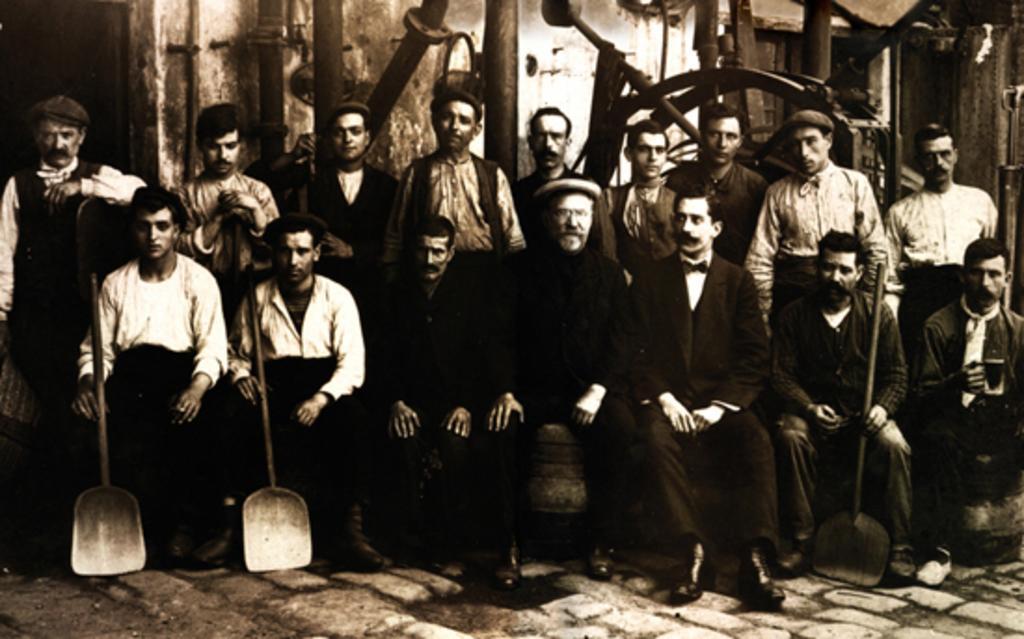Please provide a concise description of this image. In this image we can see some group of persons sitting and some are standing holding some things in their hands, posing for a photograph and in the background of the image there is a wall. 